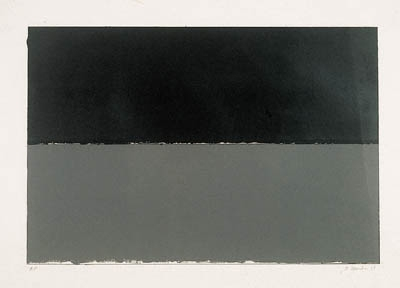What emotions do you think this piece is trying to evoke? The artwork, with its stark color contrast and minimalist approach, may evoke feelings of calmness and stillness, possibly suggesting themes of isolation or contemplation. The use of dark over light could symbolize depth or mystery, inviting the viewer to consider what lies beneath the surface or within one's own thoughts. 